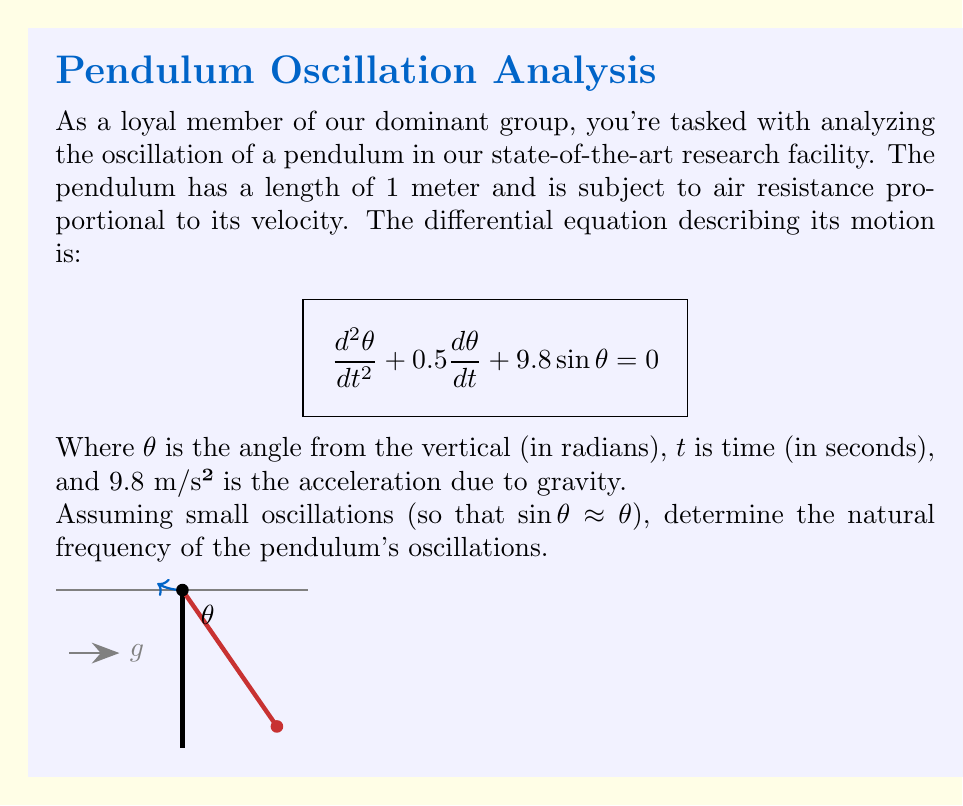Help me with this question. Let's approach this step-by-step:

1) For small oscillations, we can approximate $\sin\theta \approx \theta$. This linearizes our equation:

   $$\frac{d^2\theta}{dt^2} + 0.5\frac{d\theta}{dt} + 9.8\theta = 0$$

2) This is now in the standard form of a second-order linear differential equation:

   $$\frac{d^2\theta}{dt^2} + 2\zeta\omega_n\frac{d\theta}{dt} + \omega_n^2\theta = 0$$

   Where $\zeta$ is the damping ratio and $\omega_n$ is the natural frequency.

3) Comparing our equation to the standard form, we can see that:

   $2\zeta\omega_n = 0.5$
   $\omega_n^2 = 9.8$

4) From the second equation, we can directly calculate $\omega_n$:

   $$\omega_n = \sqrt{9.8} = 3.13 \text{ rad/s}$$

5) The natural frequency in Hz can be found by dividing by $2\pi$:

   $$f_n = \frac{\omega_n}{2\pi} = \frac{3.13}{2\pi} = 0.498 \text{ Hz}$$
Answer: $3.13 \text{ rad/s}$ or $0.498 \text{ Hz}$ 